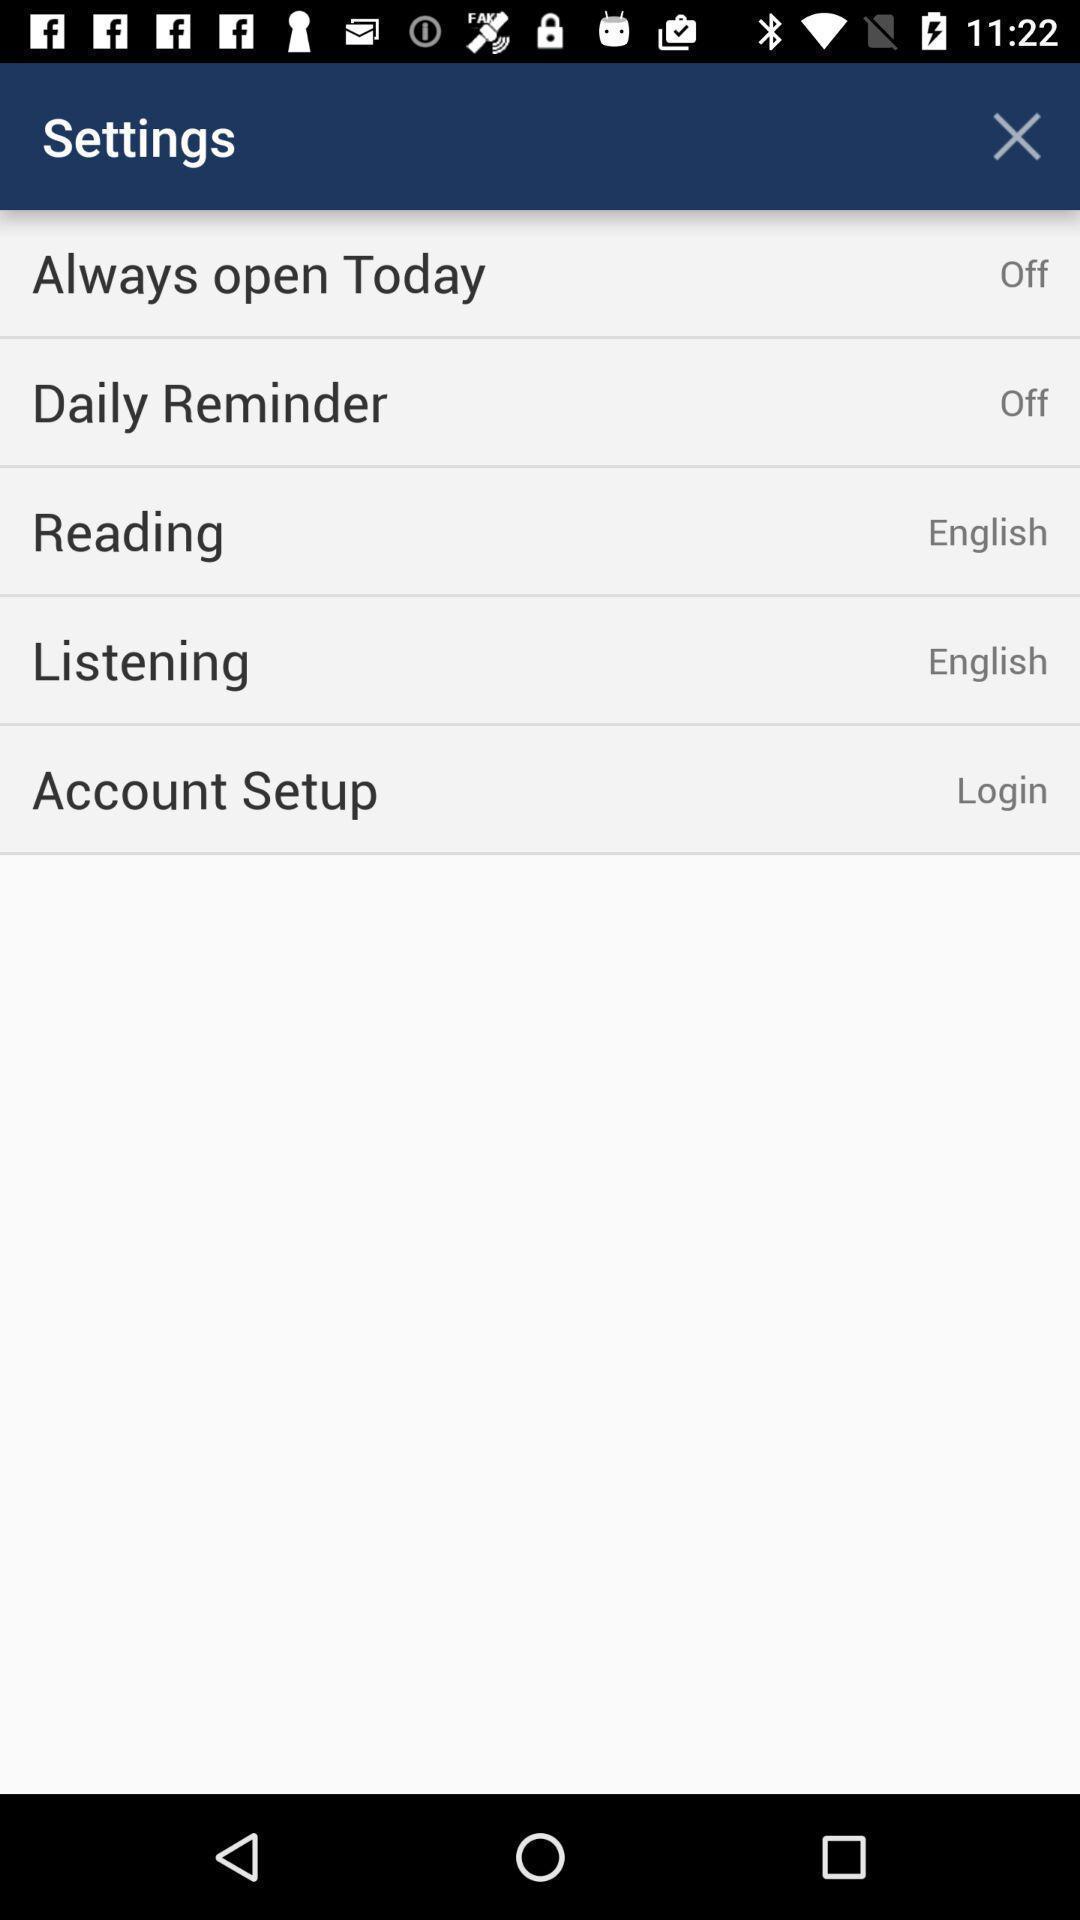Provide a textual representation of this image. Settings page displaying. 